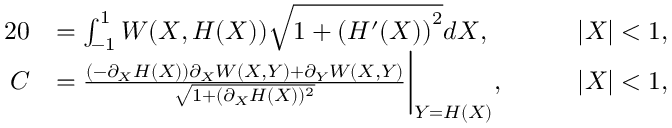<formula> <loc_0><loc_0><loc_500><loc_500>\begin{array} { r l r l } { { 2 } 0 } & { = \int _ { - 1 } ^ { 1 } W ( X , H ( X ) ) \sqrt { 1 + \left ( H ^ { \prime } ( X ) \right ) ^ { 2 } } d X , } & & { \quad | X | < 1 , } \\ { C } & { = \frac { ( - \partial _ { X } H ( X ) ) \partial _ { X } W ( X , Y ) + \partial _ { Y } W ( X , Y ) } { \sqrt { 1 + ( \partial _ { X } H ( X ) ) ^ { 2 } } } \Big | _ { Y = H ( X ) } , } & & { \quad | X | < 1 , } \end{array}</formula> 